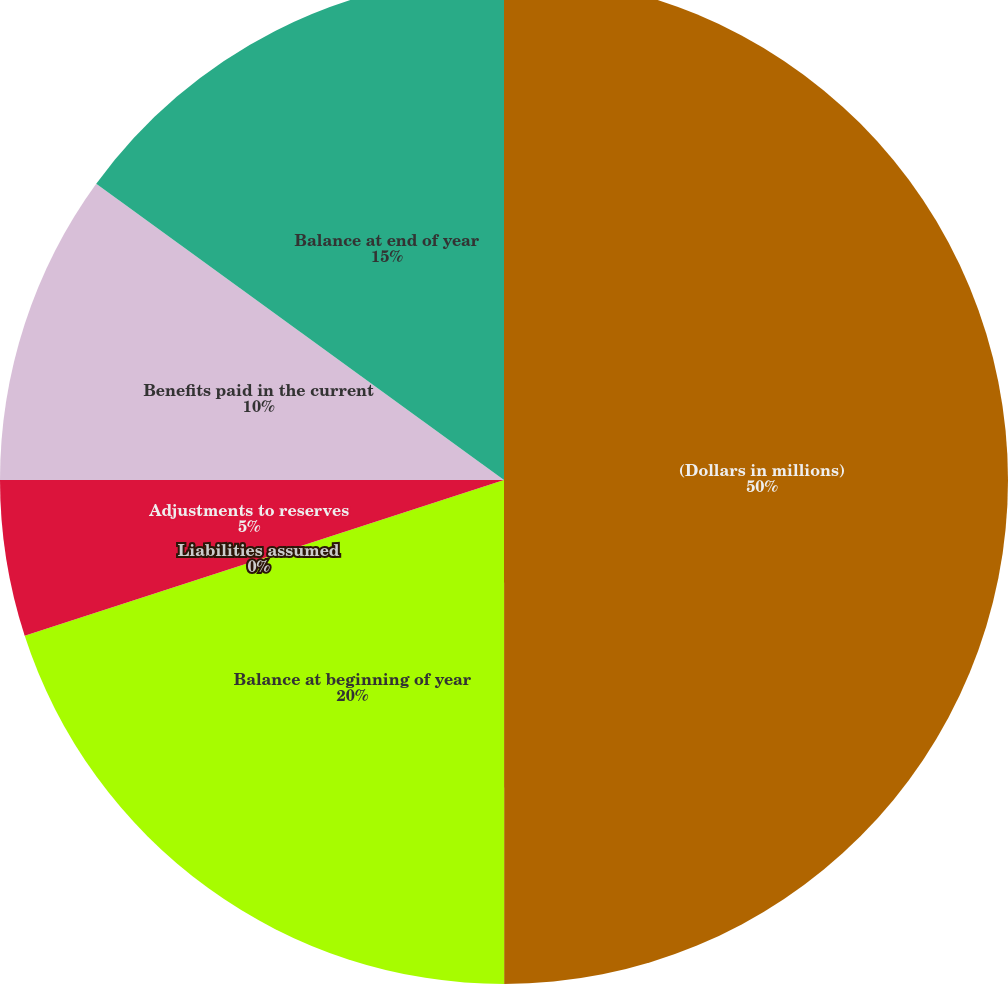Convert chart. <chart><loc_0><loc_0><loc_500><loc_500><pie_chart><fcel>(Dollars in millions)<fcel>Balance at beginning of year<fcel>Liabilities assumed<fcel>Adjustments to reserves<fcel>Benefits paid in the current<fcel>Balance at end of year<nl><fcel>49.99%<fcel>20.0%<fcel>0.0%<fcel>5.0%<fcel>10.0%<fcel>15.0%<nl></chart> 